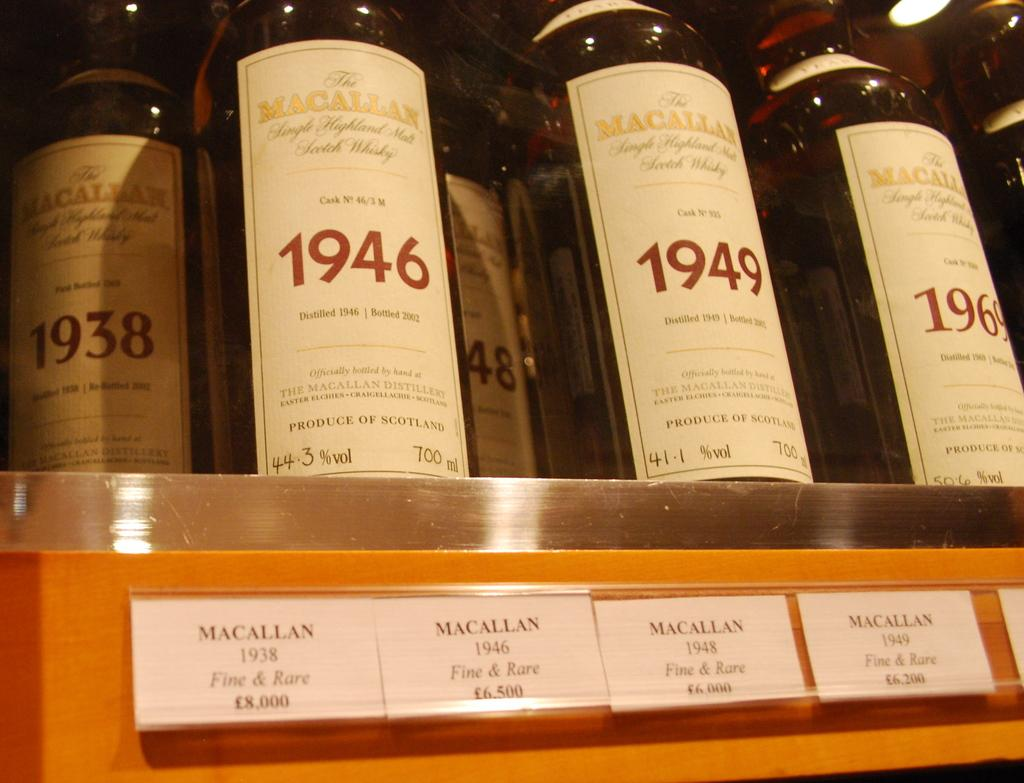<image>
Give a short and clear explanation of the subsequent image. A row of vintage Macallan wines sit in a row inside of a display case 